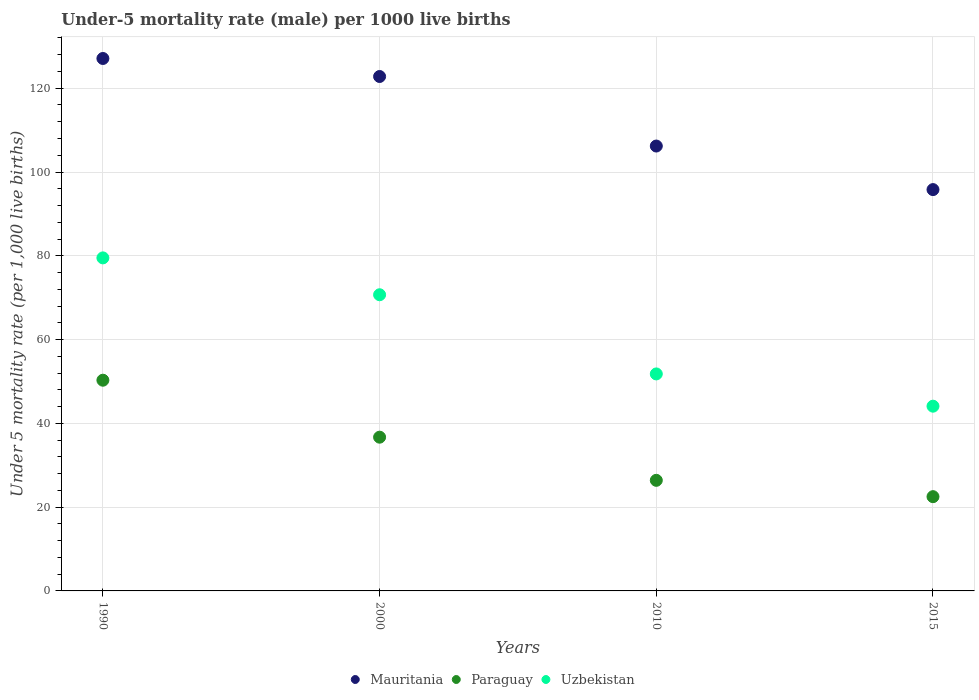How many different coloured dotlines are there?
Your answer should be compact. 3. Is the number of dotlines equal to the number of legend labels?
Provide a succinct answer. Yes. What is the under-five mortality rate in Mauritania in 2015?
Make the answer very short. 95.8. Across all years, what is the maximum under-five mortality rate in Paraguay?
Your answer should be very brief. 50.3. In which year was the under-five mortality rate in Mauritania maximum?
Offer a very short reply. 1990. In which year was the under-five mortality rate in Uzbekistan minimum?
Provide a short and direct response. 2015. What is the total under-five mortality rate in Uzbekistan in the graph?
Give a very brief answer. 246.1. What is the difference between the under-five mortality rate in Uzbekistan in 1990 and that in 2015?
Your answer should be very brief. 35.4. What is the difference between the under-five mortality rate in Mauritania in 1990 and the under-five mortality rate in Uzbekistan in 2000?
Offer a terse response. 56.4. What is the average under-five mortality rate in Paraguay per year?
Your answer should be very brief. 33.98. What is the ratio of the under-five mortality rate in Paraguay in 2010 to that in 2015?
Provide a short and direct response. 1.17. Is the under-five mortality rate in Uzbekistan in 1990 less than that in 2015?
Your answer should be compact. No. Is the difference between the under-five mortality rate in Uzbekistan in 2000 and 2015 greater than the difference between the under-five mortality rate in Paraguay in 2000 and 2015?
Your answer should be very brief. Yes. What is the difference between the highest and the second highest under-five mortality rate in Mauritania?
Give a very brief answer. 4.3. What is the difference between the highest and the lowest under-five mortality rate in Uzbekistan?
Keep it short and to the point. 35.4. Does the under-five mortality rate in Paraguay monotonically increase over the years?
Keep it short and to the point. No. How many dotlines are there?
Your response must be concise. 3. Are the values on the major ticks of Y-axis written in scientific E-notation?
Offer a very short reply. No. Does the graph contain grids?
Your answer should be very brief. Yes. How many legend labels are there?
Provide a succinct answer. 3. What is the title of the graph?
Ensure brevity in your answer.  Under-5 mortality rate (male) per 1000 live births. Does "Isle of Man" appear as one of the legend labels in the graph?
Your response must be concise. No. What is the label or title of the X-axis?
Your answer should be very brief. Years. What is the label or title of the Y-axis?
Your answer should be compact. Under 5 mortality rate (per 1,0 live births). What is the Under 5 mortality rate (per 1,000 live births) of Mauritania in 1990?
Make the answer very short. 127.1. What is the Under 5 mortality rate (per 1,000 live births) of Paraguay in 1990?
Make the answer very short. 50.3. What is the Under 5 mortality rate (per 1,000 live births) of Uzbekistan in 1990?
Offer a very short reply. 79.5. What is the Under 5 mortality rate (per 1,000 live births) in Mauritania in 2000?
Your answer should be very brief. 122.8. What is the Under 5 mortality rate (per 1,000 live births) of Paraguay in 2000?
Your answer should be compact. 36.7. What is the Under 5 mortality rate (per 1,000 live births) of Uzbekistan in 2000?
Your answer should be very brief. 70.7. What is the Under 5 mortality rate (per 1,000 live births) in Mauritania in 2010?
Provide a short and direct response. 106.2. What is the Under 5 mortality rate (per 1,000 live births) in Paraguay in 2010?
Your response must be concise. 26.4. What is the Under 5 mortality rate (per 1,000 live births) in Uzbekistan in 2010?
Your response must be concise. 51.8. What is the Under 5 mortality rate (per 1,000 live births) of Mauritania in 2015?
Offer a very short reply. 95.8. What is the Under 5 mortality rate (per 1,000 live births) in Uzbekistan in 2015?
Make the answer very short. 44.1. Across all years, what is the maximum Under 5 mortality rate (per 1,000 live births) of Mauritania?
Provide a short and direct response. 127.1. Across all years, what is the maximum Under 5 mortality rate (per 1,000 live births) of Paraguay?
Offer a terse response. 50.3. Across all years, what is the maximum Under 5 mortality rate (per 1,000 live births) in Uzbekistan?
Give a very brief answer. 79.5. Across all years, what is the minimum Under 5 mortality rate (per 1,000 live births) in Mauritania?
Your answer should be very brief. 95.8. Across all years, what is the minimum Under 5 mortality rate (per 1,000 live births) of Uzbekistan?
Your answer should be compact. 44.1. What is the total Under 5 mortality rate (per 1,000 live births) in Mauritania in the graph?
Offer a terse response. 451.9. What is the total Under 5 mortality rate (per 1,000 live births) of Paraguay in the graph?
Your answer should be compact. 135.9. What is the total Under 5 mortality rate (per 1,000 live births) of Uzbekistan in the graph?
Keep it short and to the point. 246.1. What is the difference between the Under 5 mortality rate (per 1,000 live births) of Paraguay in 1990 and that in 2000?
Ensure brevity in your answer.  13.6. What is the difference between the Under 5 mortality rate (per 1,000 live births) of Uzbekistan in 1990 and that in 2000?
Offer a very short reply. 8.8. What is the difference between the Under 5 mortality rate (per 1,000 live births) of Mauritania in 1990 and that in 2010?
Your answer should be compact. 20.9. What is the difference between the Under 5 mortality rate (per 1,000 live births) in Paraguay in 1990 and that in 2010?
Provide a succinct answer. 23.9. What is the difference between the Under 5 mortality rate (per 1,000 live births) in Uzbekistan in 1990 and that in 2010?
Make the answer very short. 27.7. What is the difference between the Under 5 mortality rate (per 1,000 live births) of Mauritania in 1990 and that in 2015?
Offer a very short reply. 31.3. What is the difference between the Under 5 mortality rate (per 1,000 live births) in Paraguay in 1990 and that in 2015?
Offer a very short reply. 27.8. What is the difference between the Under 5 mortality rate (per 1,000 live births) in Uzbekistan in 1990 and that in 2015?
Keep it short and to the point. 35.4. What is the difference between the Under 5 mortality rate (per 1,000 live births) in Paraguay in 2000 and that in 2010?
Offer a terse response. 10.3. What is the difference between the Under 5 mortality rate (per 1,000 live births) of Mauritania in 2000 and that in 2015?
Make the answer very short. 27. What is the difference between the Under 5 mortality rate (per 1,000 live births) in Paraguay in 2000 and that in 2015?
Provide a short and direct response. 14.2. What is the difference between the Under 5 mortality rate (per 1,000 live births) of Uzbekistan in 2000 and that in 2015?
Offer a very short reply. 26.6. What is the difference between the Under 5 mortality rate (per 1,000 live births) of Mauritania in 2010 and that in 2015?
Give a very brief answer. 10.4. What is the difference between the Under 5 mortality rate (per 1,000 live births) in Uzbekistan in 2010 and that in 2015?
Offer a very short reply. 7.7. What is the difference between the Under 5 mortality rate (per 1,000 live births) in Mauritania in 1990 and the Under 5 mortality rate (per 1,000 live births) in Paraguay in 2000?
Ensure brevity in your answer.  90.4. What is the difference between the Under 5 mortality rate (per 1,000 live births) in Mauritania in 1990 and the Under 5 mortality rate (per 1,000 live births) in Uzbekistan in 2000?
Your answer should be very brief. 56.4. What is the difference between the Under 5 mortality rate (per 1,000 live births) in Paraguay in 1990 and the Under 5 mortality rate (per 1,000 live births) in Uzbekistan in 2000?
Your answer should be compact. -20.4. What is the difference between the Under 5 mortality rate (per 1,000 live births) of Mauritania in 1990 and the Under 5 mortality rate (per 1,000 live births) of Paraguay in 2010?
Your response must be concise. 100.7. What is the difference between the Under 5 mortality rate (per 1,000 live births) of Mauritania in 1990 and the Under 5 mortality rate (per 1,000 live births) of Uzbekistan in 2010?
Your answer should be compact. 75.3. What is the difference between the Under 5 mortality rate (per 1,000 live births) of Mauritania in 1990 and the Under 5 mortality rate (per 1,000 live births) of Paraguay in 2015?
Offer a very short reply. 104.6. What is the difference between the Under 5 mortality rate (per 1,000 live births) of Mauritania in 1990 and the Under 5 mortality rate (per 1,000 live births) of Uzbekistan in 2015?
Ensure brevity in your answer.  83. What is the difference between the Under 5 mortality rate (per 1,000 live births) in Mauritania in 2000 and the Under 5 mortality rate (per 1,000 live births) in Paraguay in 2010?
Offer a very short reply. 96.4. What is the difference between the Under 5 mortality rate (per 1,000 live births) of Mauritania in 2000 and the Under 5 mortality rate (per 1,000 live births) of Uzbekistan in 2010?
Ensure brevity in your answer.  71. What is the difference between the Under 5 mortality rate (per 1,000 live births) of Paraguay in 2000 and the Under 5 mortality rate (per 1,000 live births) of Uzbekistan in 2010?
Offer a terse response. -15.1. What is the difference between the Under 5 mortality rate (per 1,000 live births) in Mauritania in 2000 and the Under 5 mortality rate (per 1,000 live births) in Paraguay in 2015?
Offer a very short reply. 100.3. What is the difference between the Under 5 mortality rate (per 1,000 live births) of Mauritania in 2000 and the Under 5 mortality rate (per 1,000 live births) of Uzbekistan in 2015?
Offer a terse response. 78.7. What is the difference between the Under 5 mortality rate (per 1,000 live births) of Paraguay in 2000 and the Under 5 mortality rate (per 1,000 live births) of Uzbekistan in 2015?
Offer a very short reply. -7.4. What is the difference between the Under 5 mortality rate (per 1,000 live births) of Mauritania in 2010 and the Under 5 mortality rate (per 1,000 live births) of Paraguay in 2015?
Keep it short and to the point. 83.7. What is the difference between the Under 5 mortality rate (per 1,000 live births) in Mauritania in 2010 and the Under 5 mortality rate (per 1,000 live births) in Uzbekistan in 2015?
Make the answer very short. 62.1. What is the difference between the Under 5 mortality rate (per 1,000 live births) of Paraguay in 2010 and the Under 5 mortality rate (per 1,000 live births) of Uzbekistan in 2015?
Make the answer very short. -17.7. What is the average Under 5 mortality rate (per 1,000 live births) in Mauritania per year?
Keep it short and to the point. 112.97. What is the average Under 5 mortality rate (per 1,000 live births) in Paraguay per year?
Keep it short and to the point. 33.98. What is the average Under 5 mortality rate (per 1,000 live births) in Uzbekistan per year?
Ensure brevity in your answer.  61.52. In the year 1990, what is the difference between the Under 5 mortality rate (per 1,000 live births) of Mauritania and Under 5 mortality rate (per 1,000 live births) of Paraguay?
Provide a succinct answer. 76.8. In the year 1990, what is the difference between the Under 5 mortality rate (per 1,000 live births) in Mauritania and Under 5 mortality rate (per 1,000 live births) in Uzbekistan?
Your answer should be very brief. 47.6. In the year 1990, what is the difference between the Under 5 mortality rate (per 1,000 live births) in Paraguay and Under 5 mortality rate (per 1,000 live births) in Uzbekistan?
Your answer should be compact. -29.2. In the year 2000, what is the difference between the Under 5 mortality rate (per 1,000 live births) of Mauritania and Under 5 mortality rate (per 1,000 live births) of Paraguay?
Your answer should be very brief. 86.1. In the year 2000, what is the difference between the Under 5 mortality rate (per 1,000 live births) of Mauritania and Under 5 mortality rate (per 1,000 live births) of Uzbekistan?
Give a very brief answer. 52.1. In the year 2000, what is the difference between the Under 5 mortality rate (per 1,000 live births) of Paraguay and Under 5 mortality rate (per 1,000 live births) of Uzbekistan?
Offer a terse response. -34. In the year 2010, what is the difference between the Under 5 mortality rate (per 1,000 live births) of Mauritania and Under 5 mortality rate (per 1,000 live births) of Paraguay?
Offer a very short reply. 79.8. In the year 2010, what is the difference between the Under 5 mortality rate (per 1,000 live births) in Mauritania and Under 5 mortality rate (per 1,000 live births) in Uzbekistan?
Keep it short and to the point. 54.4. In the year 2010, what is the difference between the Under 5 mortality rate (per 1,000 live births) in Paraguay and Under 5 mortality rate (per 1,000 live births) in Uzbekistan?
Offer a very short reply. -25.4. In the year 2015, what is the difference between the Under 5 mortality rate (per 1,000 live births) of Mauritania and Under 5 mortality rate (per 1,000 live births) of Paraguay?
Your answer should be compact. 73.3. In the year 2015, what is the difference between the Under 5 mortality rate (per 1,000 live births) of Mauritania and Under 5 mortality rate (per 1,000 live births) of Uzbekistan?
Your response must be concise. 51.7. In the year 2015, what is the difference between the Under 5 mortality rate (per 1,000 live births) of Paraguay and Under 5 mortality rate (per 1,000 live births) of Uzbekistan?
Ensure brevity in your answer.  -21.6. What is the ratio of the Under 5 mortality rate (per 1,000 live births) in Mauritania in 1990 to that in 2000?
Your answer should be compact. 1.03. What is the ratio of the Under 5 mortality rate (per 1,000 live births) in Paraguay in 1990 to that in 2000?
Keep it short and to the point. 1.37. What is the ratio of the Under 5 mortality rate (per 1,000 live births) in Uzbekistan in 1990 to that in 2000?
Give a very brief answer. 1.12. What is the ratio of the Under 5 mortality rate (per 1,000 live births) in Mauritania in 1990 to that in 2010?
Your answer should be compact. 1.2. What is the ratio of the Under 5 mortality rate (per 1,000 live births) of Paraguay in 1990 to that in 2010?
Provide a short and direct response. 1.91. What is the ratio of the Under 5 mortality rate (per 1,000 live births) of Uzbekistan in 1990 to that in 2010?
Give a very brief answer. 1.53. What is the ratio of the Under 5 mortality rate (per 1,000 live births) of Mauritania in 1990 to that in 2015?
Provide a short and direct response. 1.33. What is the ratio of the Under 5 mortality rate (per 1,000 live births) of Paraguay in 1990 to that in 2015?
Give a very brief answer. 2.24. What is the ratio of the Under 5 mortality rate (per 1,000 live births) in Uzbekistan in 1990 to that in 2015?
Make the answer very short. 1.8. What is the ratio of the Under 5 mortality rate (per 1,000 live births) in Mauritania in 2000 to that in 2010?
Keep it short and to the point. 1.16. What is the ratio of the Under 5 mortality rate (per 1,000 live births) of Paraguay in 2000 to that in 2010?
Give a very brief answer. 1.39. What is the ratio of the Under 5 mortality rate (per 1,000 live births) of Uzbekistan in 2000 to that in 2010?
Ensure brevity in your answer.  1.36. What is the ratio of the Under 5 mortality rate (per 1,000 live births) of Mauritania in 2000 to that in 2015?
Provide a succinct answer. 1.28. What is the ratio of the Under 5 mortality rate (per 1,000 live births) in Paraguay in 2000 to that in 2015?
Provide a succinct answer. 1.63. What is the ratio of the Under 5 mortality rate (per 1,000 live births) of Uzbekistan in 2000 to that in 2015?
Provide a short and direct response. 1.6. What is the ratio of the Under 5 mortality rate (per 1,000 live births) of Mauritania in 2010 to that in 2015?
Keep it short and to the point. 1.11. What is the ratio of the Under 5 mortality rate (per 1,000 live births) in Paraguay in 2010 to that in 2015?
Provide a succinct answer. 1.17. What is the ratio of the Under 5 mortality rate (per 1,000 live births) in Uzbekistan in 2010 to that in 2015?
Your answer should be very brief. 1.17. What is the difference between the highest and the lowest Under 5 mortality rate (per 1,000 live births) of Mauritania?
Provide a short and direct response. 31.3. What is the difference between the highest and the lowest Under 5 mortality rate (per 1,000 live births) in Paraguay?
Keep it short and to the point. 27.8. What is the difference between the highest and the lowest Under 5 mortality rate (per 1,000 live births) of Uzbekistan?
Offer a very short reply. 35.4. 